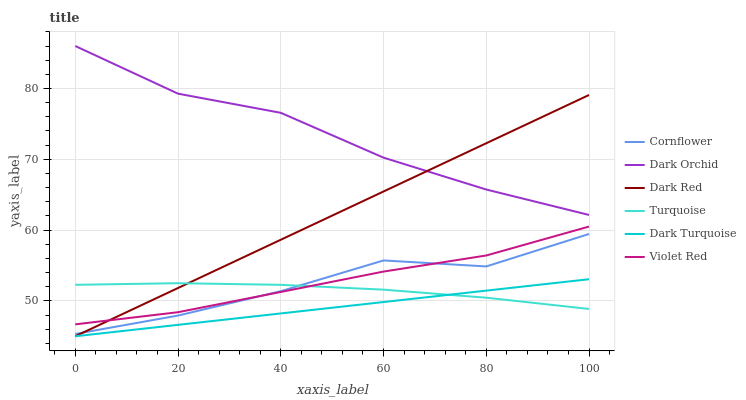Does Dark Turquoise have the minimum area under the curve?
Answer yes or no. Yes. Does Dark Orchid have the maximum area under the curve?
Answer yes or no. Yes. Does Turquoise have the minimum area under the curve?
Answer yes or no. No. Does Turquoise have the maximum area under the curve?
Answer yes or no. No. Is Dark Red the smoothest?
Answer yes or no. Yes. Is Cornflower the roughest?
Answer yes or no. Yes. Is Turquoise the smoothest?
Answer yes or no. No. Is Turquoise the roughest?
Answer yes or no. No. Does Turquoise have the lowest value?
Answer yes or no. No. Does Dark Orchid have the highest value?
Answer yes or no. Yes. Does Dark Turquoise have the highest value?
Answer yes or no. No. Is Dark Turquoise less than Dark Orchid?
Answer yes or no. Yes. Is Dark Orchid greater than Dark Turquoise?
Answer yes or no. Yes. Does Dark Turquoise intersect Dark Orchid?
Answer yes or no. No. 